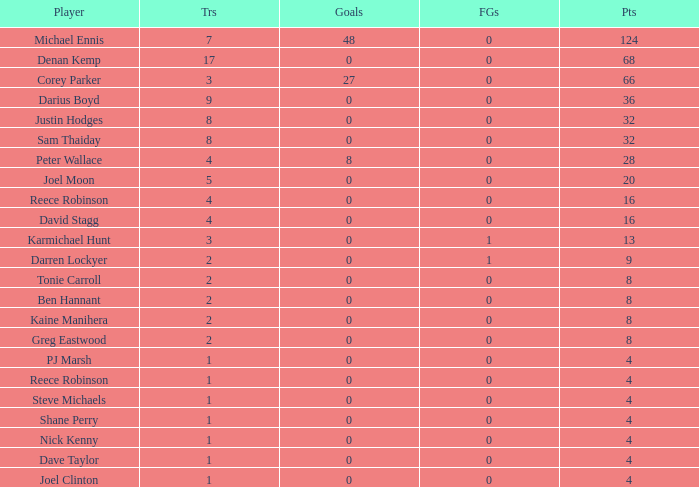How many goals did the player with less than 4 points have? 0.0. 